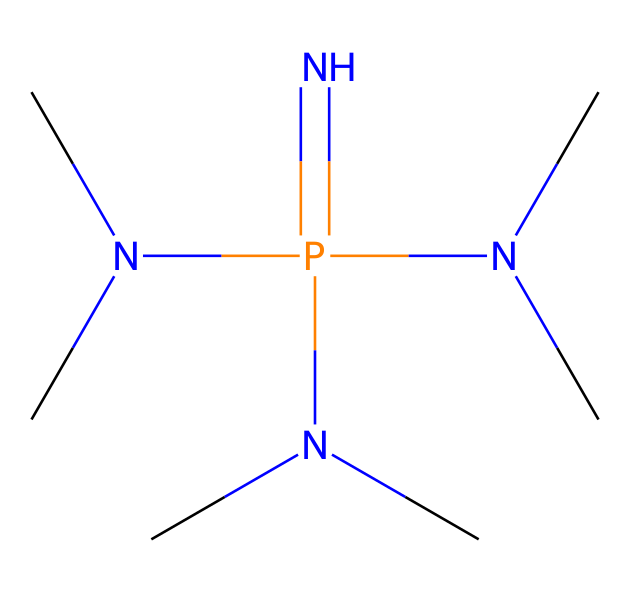What is the main functional group present in this structure? The structure contains multiple nitrogen atoms bonded to a phosphorus atom, indicating that the main functional group is the phosphazene group.
Answer: phosphazene group How many nitrogen atoms are present in the structure? By examining the SMILES representation, there are four nitrogen atoms in the structure that are bonded directly to phosphorus and as substituents.
Answer: four What is the total number of methyl groups attached to the nitrogen atoms? Each of the three terminal nitrogen atoms has one methyl group attached; therefore, there are a total of three methyl groups in the structure.
Answer: three What type of chemical compound is represented by this structure? This chemical structure belongs to the class of superbases due to the presence of multiple basic nitrogen atoms capable of donating electrons.
Answer: superbase What is the hybridization state of the phosphorus atom in this chemical? The phosphorus atom is bonded to multiple nitrogen atoms which suggests that it has a hybridization state of sp3 due to the four substituents around it.
Answer: sp3 How does the presence of multiple nitrogen atoms affect the basicity of the compound? Having multiple nitrogen atoms increases the basicity of the compound due to the electron-donating ability of nitrogen, which stabilizes positive charges and enhances reactivity.
Answer: increases basicity 